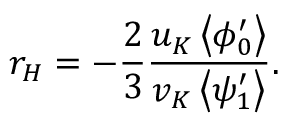Convert formula to latex. <formula><loc_0><loc_0><loc_500><loc_500>r _ { H } = - \frac { 2 } { 3 } \frac { u _ { K } \left < \phi _ { 0 } ^ { \prime } \right > } { v _ { K } \left < \psi _ { 1 } ^ { \prime } \right > } .</formula> 